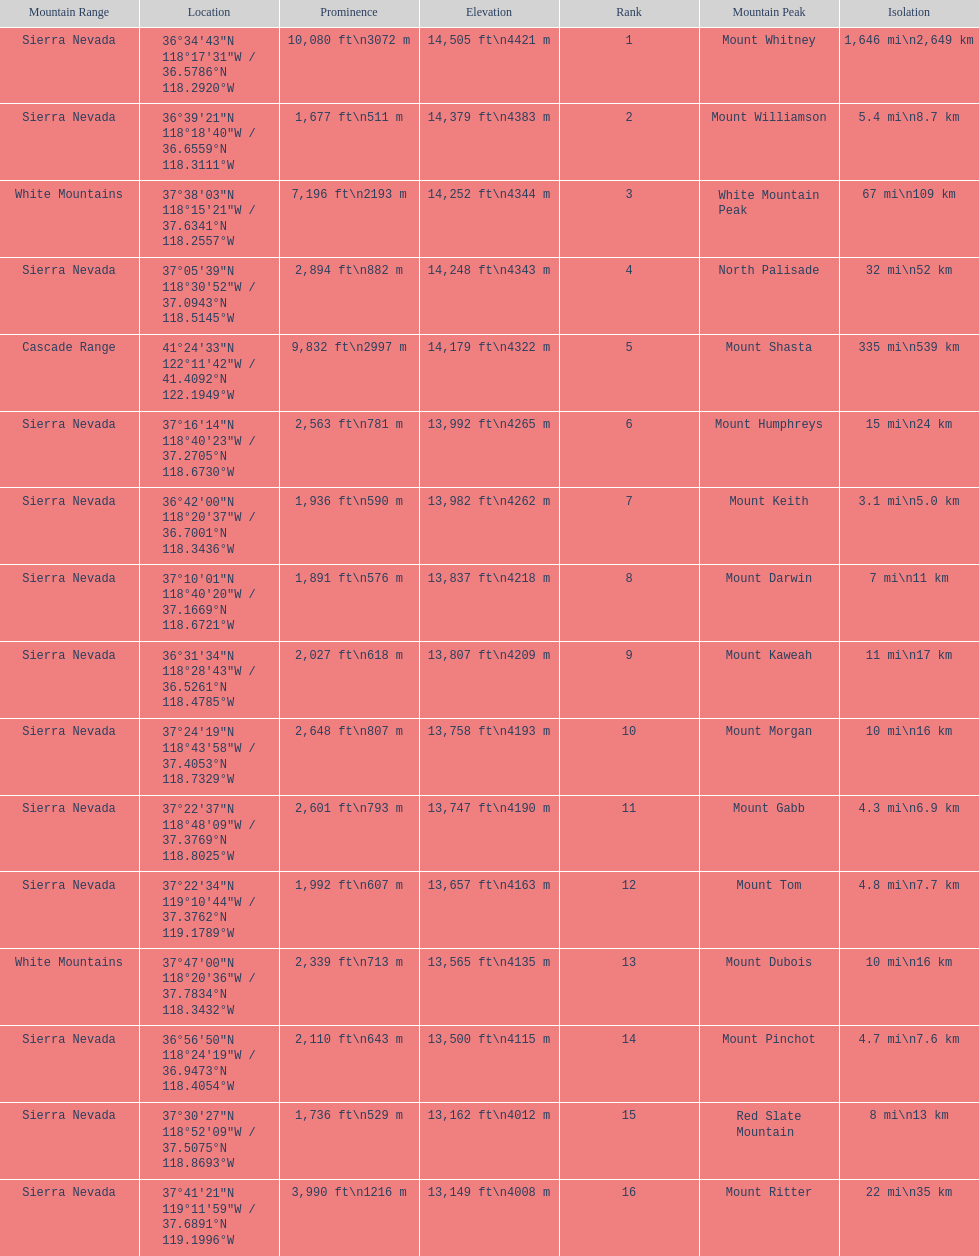Which mountain peak is no higher than 13,149 ft? Mount Ritter. 